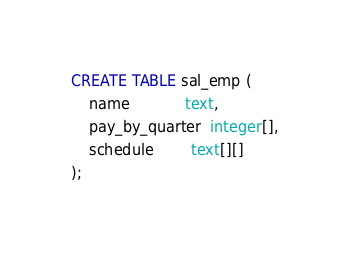<code> <loc_0><loc_0><loc_500><loc_500><_SQL_>CREATE TABLE sal_emp (
    name            text,
    pay_by_quarter  integer[],
    schedule        text[][]
);
</code> 